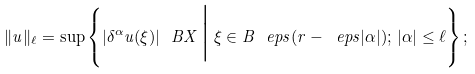<formula> <loc_0><loc_0><loc_500><loc_500>\| u \| _ { \ell } = \sup \left \{ | \delta ^ { \alpha } u ( \xi ) | _ { \ } B X \, \Big { | } \, \xi \in B ^ { \ } e p s ( r - \ e p s | \alpha | ) ; \, | \alpha | \leq \ell \right \} ;</formula> 